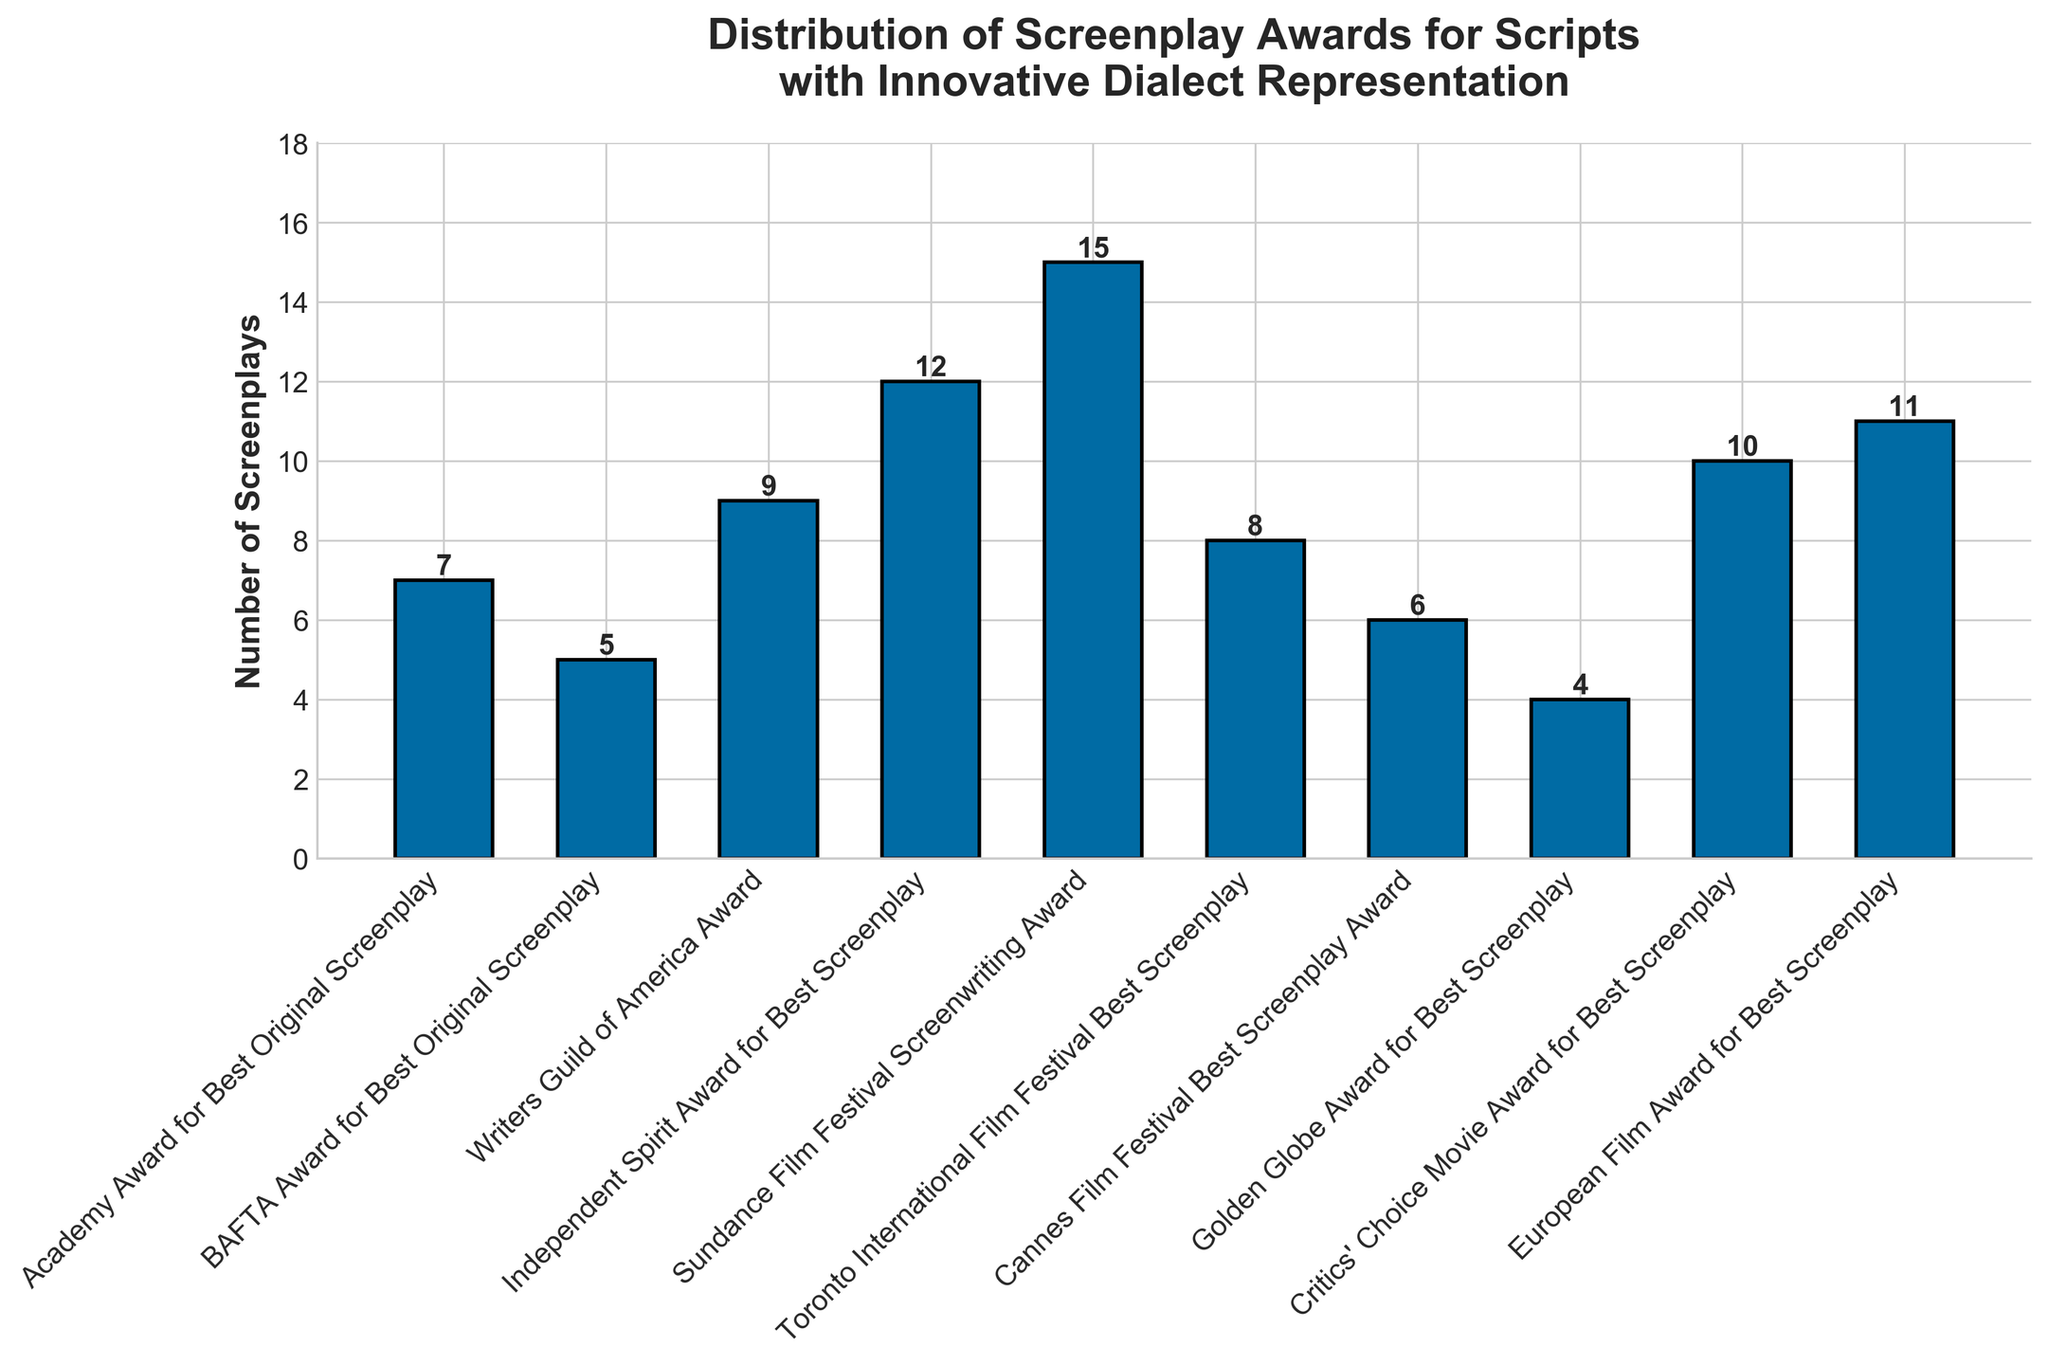Which award category received the highest number of screenplays? The highest bar corresponds to the Sundance Film Festival Screenwriting Award, which reaches the highest numerical value on the y-axis with 15 screenplays.
Answer: Sundance Film Festival Screenwriting Award How many more screenplays did the European Film Award for Best Screenplay receive compared to the Golden Globe Award for Best Screenplay? The European Film Award for Best Screenplay had 11 screenplays, while the Golden Globe Award for Best Screenplay had 4 screenplays, giving a difference of 11 - 4 = 7 screenplays.
Answer: 7 What is the total number of screenplays that received Writers Guild of America Award, BAFTA Award for Best Original Screenplay, and Independent Spirit Award for Best Screenplay combined? Adding the numbers: 9 (Writers Guild of America) + 5 (BAFTA) + 12 (Independent Spirit) = 26 screenplays in total.
Answer: 26 Which award category has the smallest number of screenplays, and how many are there? The shortest bar corresponds to the Golden Globe Award for Best Screenplay, which has 4 screenplays.
Answer: Golden Globe Award for Best Screenplay, 4 Which two award categories have the closest number of screenplays received, and what is the difference between them? The Cannes Film Festival Screenplay Award has 6 screenplays, and the Academy Award for Best Original Screenplay has 7 screenplays; the difference between them is
Answer: 1 Which awards received exactly 9 and 10 screenplays? By matching the numerical values to the bars, the Writers Guild of America Award received 9 screenplays, and the Critics' Choice Movie Award for Best Screenplay received 10 screenplays.
Answer: Writers Guild of America Award and Critics' Choice Movie Award for Best Screenplay What is the average number of screenplays received by all the awards listed? Sum all the screenplays: 7 + 5 + 9 + 12 + 15 + 8 + 6 + 4 + 10 + 11 = 87 screenplays. There are 10 awards, so the average is 87 / 10 = 8.7 screenplays.
Answer: 8.7 How many screenplays in total did the top three award categories receive? The top three are the Sundance Film Festival Screenwriting Award (15), Independent Spirit Award for Best Screenplay (12), and European Film Award for Best Screenplay (11). Summing up: 15 + 12 + 11 = 38 screenplays.
Answer: 38 How many more screenplays did the Sundance Film Festival Screenwriting Award receive compared to the average number of screenplays per award? Average number of screenplays is 8.7. The Sundance Film Festival Screenwriting Award received 15; difference is 15 - 8.7 = 6.3.
Answer: 6.3 